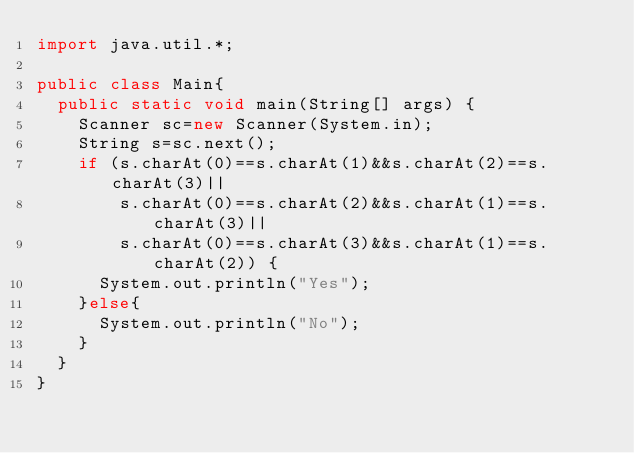<code> <loc_0><loc_0><loc_500><loc_500><_Java_>import java.util.*;

public class Main{
  public static void main(String[] args) {
    Scanner sc=new Scanner(System.in);
    String s=sc.next();
    if (s.charAt(0)==s.charAt(1)&&s.charAt(2)==s.charAt(3)||
        s.charAt(0)==s.charAt(2)&&s.charAt(1)==s.charAt(3)||
        s.charAt(0)==s.charAt(3)&&s.charAt(1)==s.charAt(2)) {
      System.out.println("Yes");
    }else{
      System.out.println("No");
    }
  }
}
</code> 